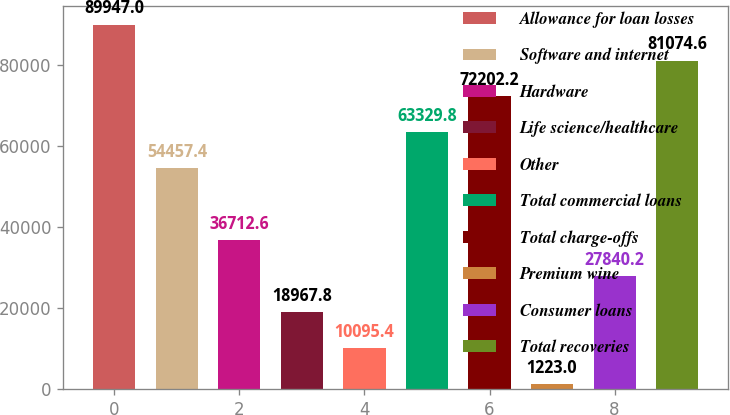Convert chart to OTSL. <chart><loc_0><loc_0><loc_500><loc_500><bar_chart><fcel>Allowance for loan losses<fcel>Software and internet<fcel>Hardware<fcel>Life science/healthcare<fcel>Other<fcel>Total commercial loans<fcel>Total charge-offs<fcel>Premium wine<fcel>Consumer loans<fcel>Total recoveries<nl><fcel>89947<fcel>54457.4<fcel>36712.6<fcel>18967.8<fcel>10095.4<fcel>63329.8<fcel>72202.2<fcel>1223<fcel>27840.2<fcel>81074.6<nl></chart> 